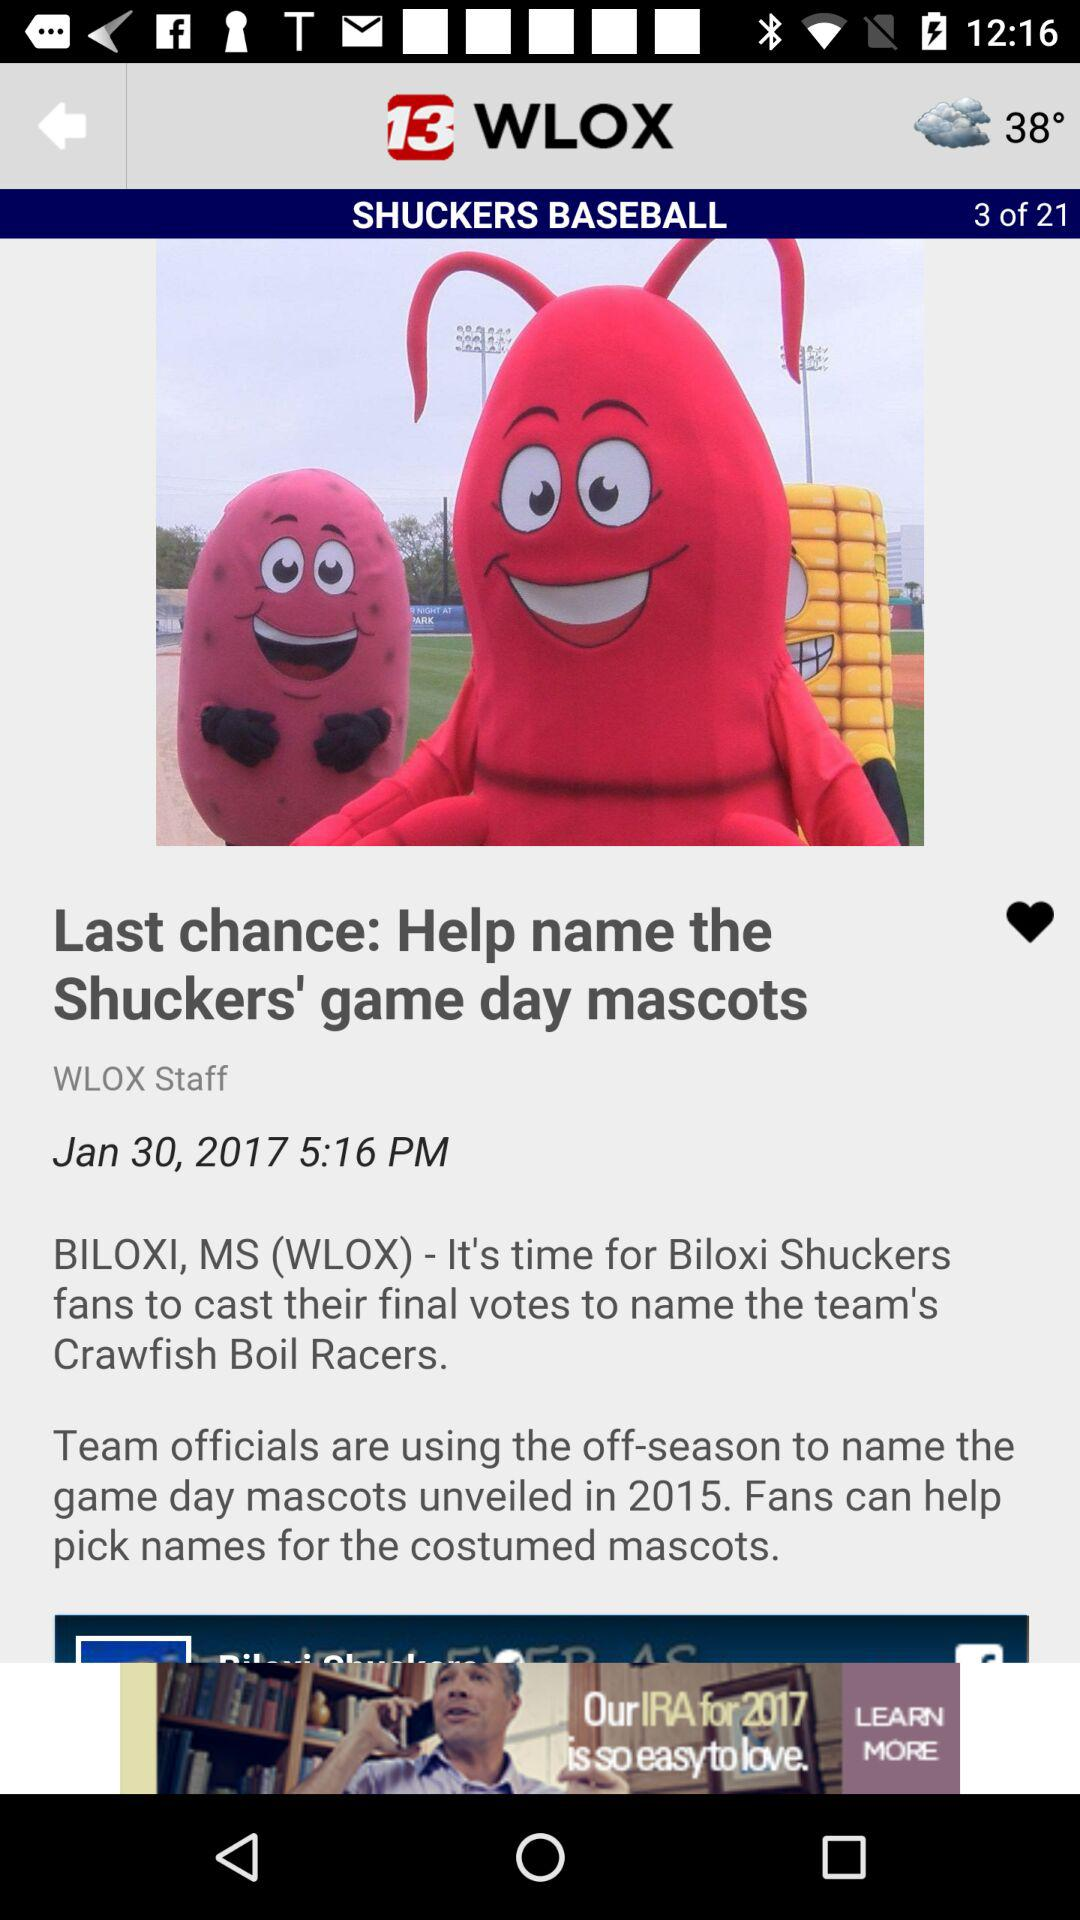How many articles are there? There are 21 articles. 